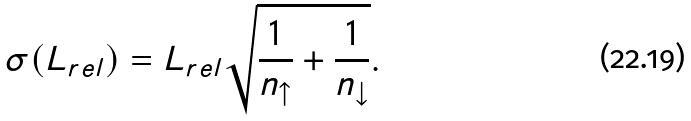<formula> <loc_0><loc_0><loc_500><loc_500>\sigma ( L _ { r e l } ) = L _ { r e l } \sqrt { \frac { 1 } { n _ { \uparrow } } + \frac { 1 } { n _ { \downarrow } } } .</formula> 